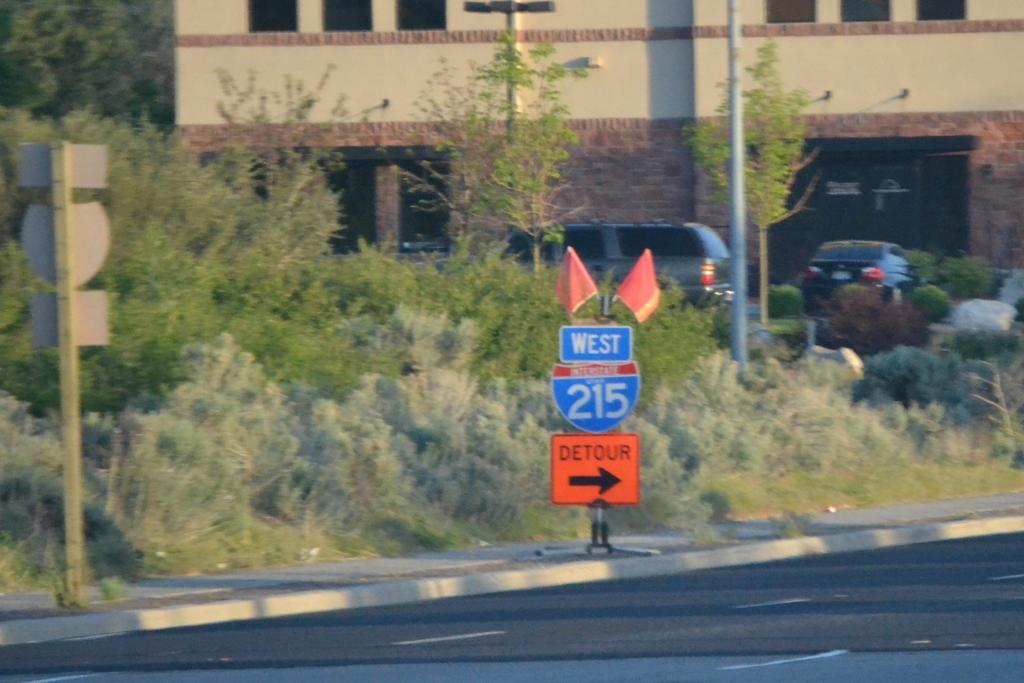Provide a one-sentence caption for the provided image. A road sign that shows a detour on to West 215. 